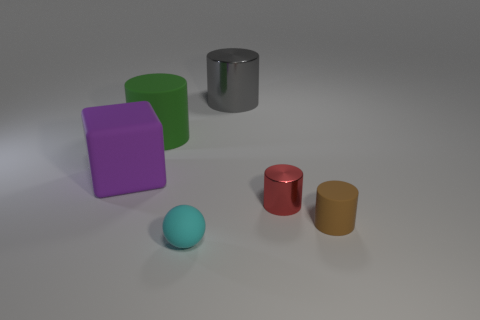What shape is the cyan thing that is the same material as the big purple block?
Give a very brief answer. Sphere. Do the big purple thing and the tiny object right of the red shiny cylinder have the same shape?
Ensure brevity in your answer.  No. What material is the large cylinder that is right of the tiny rubber thing in front of the brown cylinder?
Your response must be concise. Metal. Are there an equal number of green cylinders in front of the large shiny thing and tiny brown objects?
Ensure brevity in your answer.  Yes. Is there anything else that is the same material as the purple block?
Your response must be concise. Yes. There is a tiny matte thing that is to the left of the big gray thing; does it have the same color as the tiny cylinder that is to the right of the small metallic cylinder?
Your response must be concise. No. What number of cylinders are both behind the large purple thing and on the right side of the big green thing?
Make the answer very short. 1. What number of other objects are there of the same shape as the big gray shiny object?
Provide a succinct answer. 3. Is the number of things left of the big purple cube greater than the number of small things?
Ensure brevity in your answer.  No. There is a big cylinder to the left of the small cyan rubber object; what color is it?
Offer a very short reply. Green. 